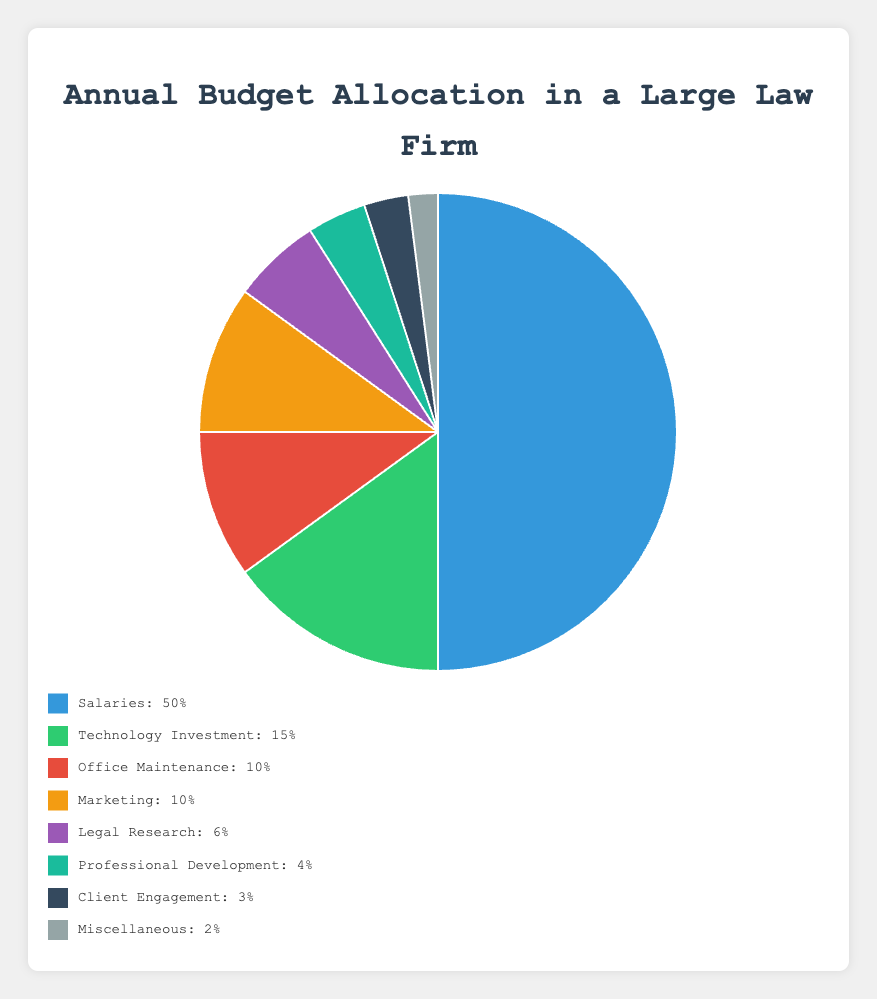What is the total percentage allocated to Office Maintenance and Marketing combined? The percentage for Office Maintenance is 10%, and for Marketing, it is also 10%. Adding these together, the total percentage allocated to both categories is 10% + 10% = 20%.
Answer: 20% Which category receives the highest percentage of the annual budget? The Salaries category receives 50% of the annual budget, which is higher than any other category in the chart.
Answer: Salaries Is the budget for Professional Development greater than the budget for Client Engagement? The percentage allocated for Professional Development is 4%, while for Client Engagement, it is 3%. Since 4% is greater than 3%, the budget for Professional Development is indeed greater.
Answer: Yes What is the combined percentage of the three smallest budget allocations? The three smallest allocations are Miscellaneous (2%), Client Engagement (3%), and Professional Development (4%). Summing these gives 2% + 3% + 4% = 9%.
Answer: 9% How much more budget is allocated to Technology Investment compared to Legal Research? The percentage allocated to Technology Investment is 15%, and to Legal Research is 6%. The difference is 15% - 6% = 9%.
Answer: 9% Which two categories together make up exactly 20% of the annual budget? Office Maintenance and Marketing both individually have 10% of the budget each. Together, they make up 10% + 10% = 20%.
Answer: Office Maintenance and Marketing What is the difference between the highest and the lowest budget allocation categories? The highest category is Salaries at 50%, and the lowest is Miscellaneous at 2%. The difference is 50% - 2% = 48%.
Answer: 48% Which category is represented by the green section in the pie chart? In the pie chart, the green section represents Technology Investment, which has a budget allocation of 15%.
Answer: Technology Investment Is the budget for Legal Research equal to the budget for Professional Development and Client Engagement combined? Legal Research receives 6% of the budget. Professional Development (4%) combined with Client Engagement (3%) totals 4% + 3% = 7%. Therefore, Legal Research is not equal to this sum.
Answer: No 